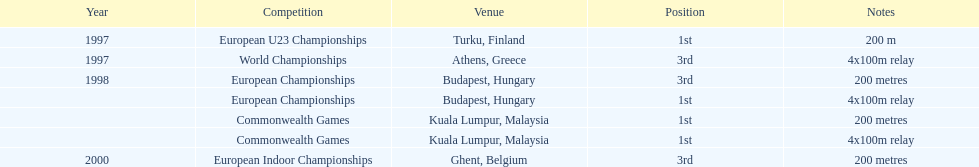What was the length of the sprint during the 2000 european indoor championships competition? 200 metres. 